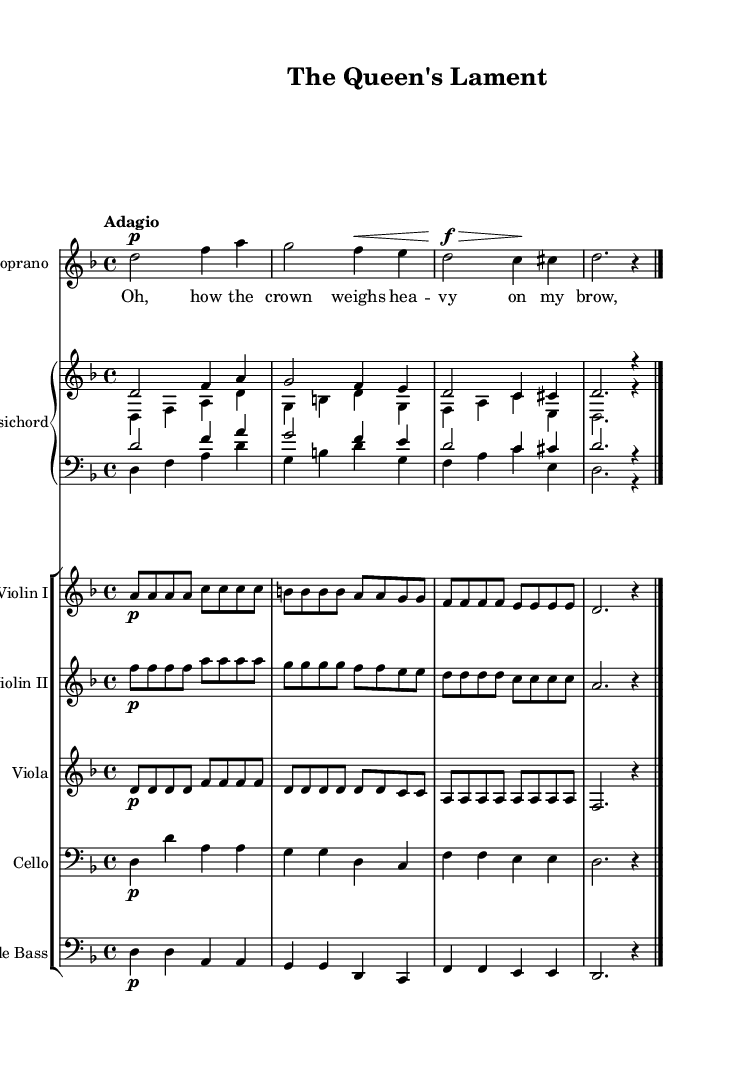What is the key signature of this music? The key signature is D minor, which has one flat (B flat). This can be inferred from the initial key signature marking at the beginning of the score which indicates D minor.
Answer: D minor What is the time signature of the music? The time signature is 4/4, indicated at the beginning of the music. This means there are four beats in each measure, with the quarter note getting one beat.
Answer: 4/4 What is the tempo marking for this piece? The tempo marking is "Adagio," which indicates a slow and stately pace. This is specified at the beginning of the score.
Answer: Adagio How many measures does the soprano part have? The soprano part consists of 4 measures, which is determined by counting the bar lines in the staff for the soprano part.
Answer: 4 Which instrument features the lower staff for the harpsichord? The lower staff for the harpsichord is designated as the bass clef, indicating that it plays the lower range of notes. This is stated explicitly in the staff grouping for the harpsichord.
Answer: C clef What type of operatic role does the piece represent? The piece represents a powerful female protagonist, which is characteristic of many Baroque operas that emphasize strong female voices and dramatic roles. This is inferred from the title and the emotional context of the soprano's lament.
Answer: Female protagonist 